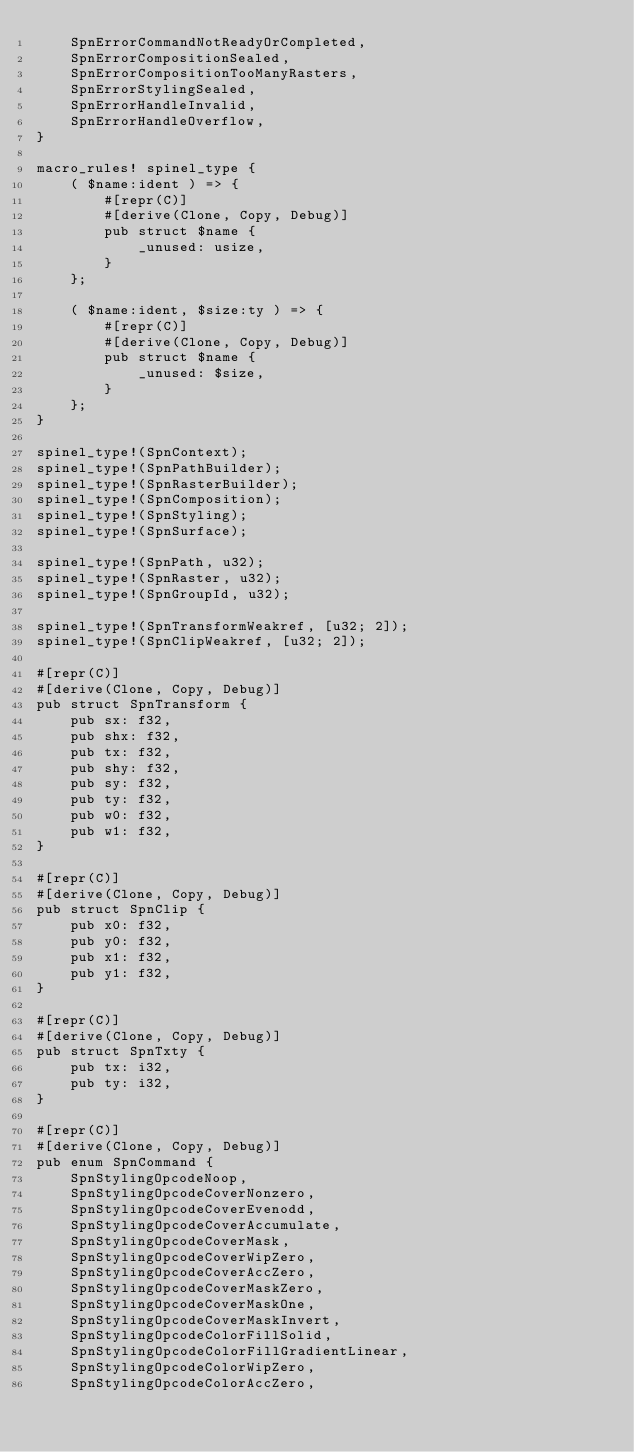<code> <loc_0><loc_0><loc_500><loc_500><_Rust_>    SpnErrorCommandNotReadyOrCompleted,
    SpnErrorCompositionSealed,
    SpnErrorCompositionTooManyRasters,
    SpnErrorStylingSealed,
    SpnErrorHandleInvalid,
    SpnErrorHandleOverflow,
}

macro_rules! spinel_type {
    ( $name:ident ) => {
        #[repr(C)]
        #[derive(Clone, Copy, Debug)]
        pub struct $name {
            _unused: usize,
        }
    };

    ( $name:ident, $size:ty ) => {
        #[repr(C)]
        #[derive(Clone, Copy, Debug)]
        pub struct $name {
            _unused: $size,
        }
    };
}

spinel_type!(SpnContext);
spinel_type!(SpnPathBuilder);
spinel_type!(SpnRasterBuilder);
spinel_type!(SpnComposition);
spinel_type!(SpnStyling);
spinel_type!(SpnSurface);

spinel_type!(SpnPath, u32);
spinel_type!(SpnRaster, u32);
spinel_type!(SpnGroupId, u32);

spinel_type!(SpnTransformWeakref, [u32; 2]);
spinel_type!(SpnClipWeakref, [u32; 2]);

#[repr(C)]
#[derive(Clone, Copy, Debug)]
pub struct SpnTransform {
    pub sx: f32,
    pub shx: f32,
    pub tx: f32,
    pub shy: f32,
    pub sy: f32,
    pub ty: f32,
    pub w0: f32,
    pub w1: f32,
}

#[repr(C)]
#[derive(Clone, Copy, Debug)]
pub struct SpnClip {
    pub x0: f32,
    pub y0: f32,
    pub x1: f32,
    pub y1: f32,
}

#[repr(C)]
#[derive(Clone, Copy, Debug)]
pub struct SpnTxty {
    pub tx: i32,
    pub ty: i32,
}

#[repr(C)]
#[derive(Clone, Copy, Debug)]
pub enum SpnCommand {
    SpnStylingOpcodeNoop,
    SpnStylingOpcodeCoverNonzero,
    SpnStylingOpcodeCoverEvenodd,
    SpnStylingOpcodeCoverAccumulate,
    SpnStylingOpcodeCoverMask,
    SpnStylingOpcodeCoverWipZero,
    SpnStylingOpcodeCoverAccZero,
    SpnStylingOpcodeCoverMaskZero,
    SpnStylingOpcodeCoverMaskOne,
    SpnStylingOpcodeCoverMaskInvert,
    SpnStylingOpcodeColorFillSolid,
    SpnStylingOpcodeColorFillGradientLinear,
    SpnStylingOpcodeColorWipZero,
    SpnStylingOpcodeColorAccZero,</code> 